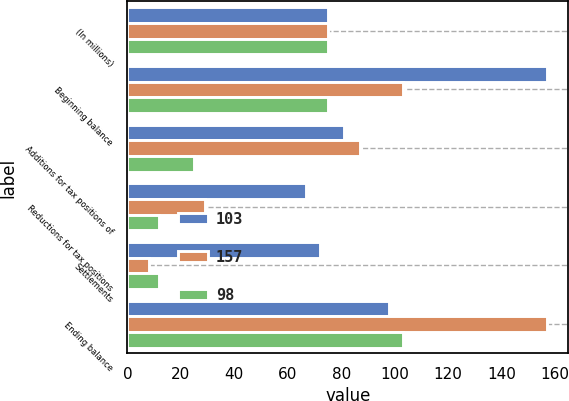Convert chart. <chart><loc_0><loc_0><loc_500><loc_500><stacked_bar_chart><ecel><fcel>(In millions)<fcel>Beginning balance<fcel>Additions for tax positions of<fcel>Reductions for tax positions<fcel>Settlements<fcel>Ending balance<nl><fcel>103<fcel>75<fcel>157<fcel>81<fcel>67<fcel>72<fcel>98<nl><fcel>157<fcel>75<fcel>103<fcel>87<fcel>29<fcel>8<fcel>157<nl><fcel>98<fcel>75<fcel>75<fcel>25<fcel>12<fcel>12<fcel>103<nl></chart> 